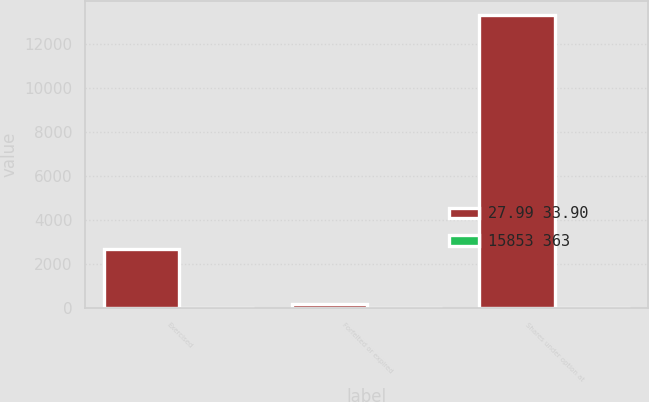Convert chart. <chart><loc_0><loc_0><loc_500><loc_500><stacked_bar_chart><ecel><fcel>Exercised<fcel>Forfeited or expired<fcel>Shares under option at<nl><fcel>27.99 33.90<fcel>2713<fcel>199<fcel>13304<nl><fcel>15853 363<fcel>26.98<fcel>31.28<fcel>28.31<nl></chart> 